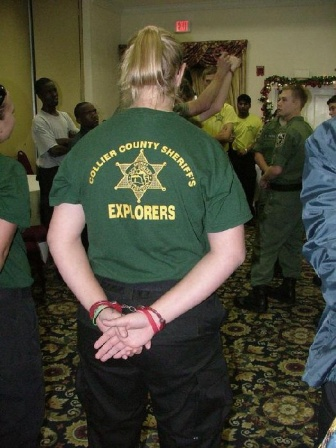Imagine this image is from a fictional story. What would be the story behind this scene? In a small, close-knit town, the Collier County Sheriff's Explorers were more than just a community group; they were a symbol of hope and unity. This holiday season, the Sheriff's Explorers had organized a special event to honor their community's resilience and spirit. As part of their tradition, they invited the town's most respected deputy, Officer Davis, to lead a heartfelt ceremony. In the spirit of gratitude, the young explorers donned their green shirts and shared stories of how they had helped their neighbors throughout the year. Amidst the festive cheer and the glow of Christmas decorations, the group pledged to continue their service, inspired by the words and wisdom of Officer Davis. Their commitment to their town would sow the seeds of kindness and grow a stronger, more connected community. What are some events or activities that this group might be involved in, considering their t-shirts and the context? The Collier County Sheriff's Explorers are likely engaged in a variety of community-building and educational activities. Given the festive setting in the image, they might be hosting a holiday party or celebration, which could include activities like gift exchanges, community service projects, or educational presentations about safety and law enforcement. During the year, they could be involved in things like community clean-ups, assisting at local events, participating in ride-alongs with deputies, and attending workshops or training sessions that teach them about law enforcement protocols and community service. Their role fosters leadership, responsibility, and civic engagement among the youth. 